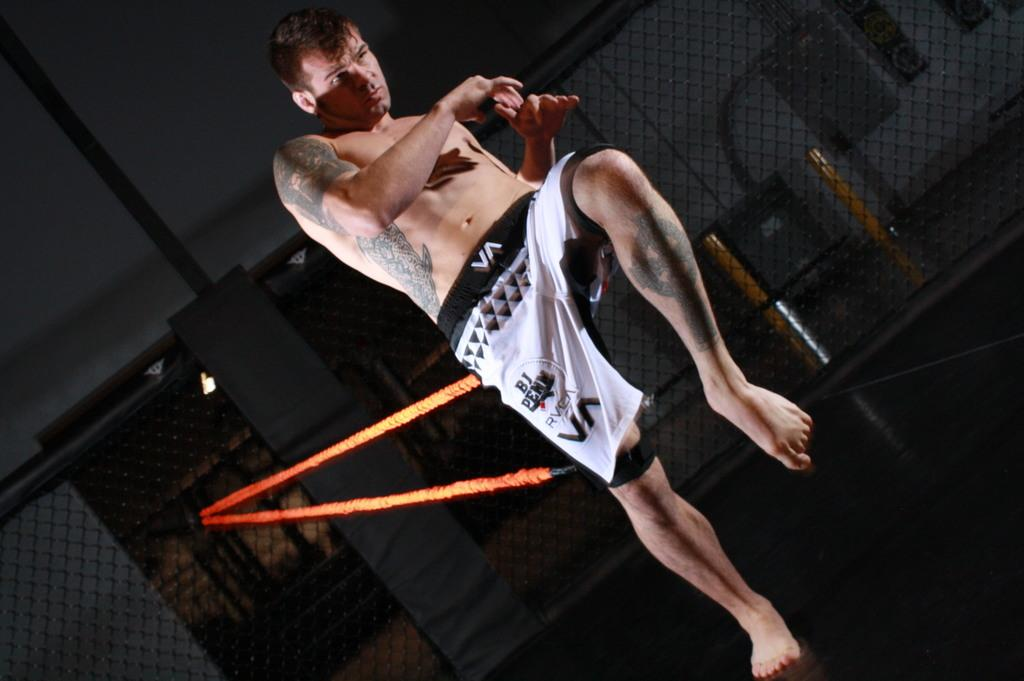Provide a one-sentence caption for the provided image. A kickboxer training with some shorts that say BJ on it. 